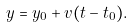<formula> <loc_0><loc_0><loc_500><loc_500>y = y _ { 0 } + v ( t - t _ { 0 } ) .</formula> 